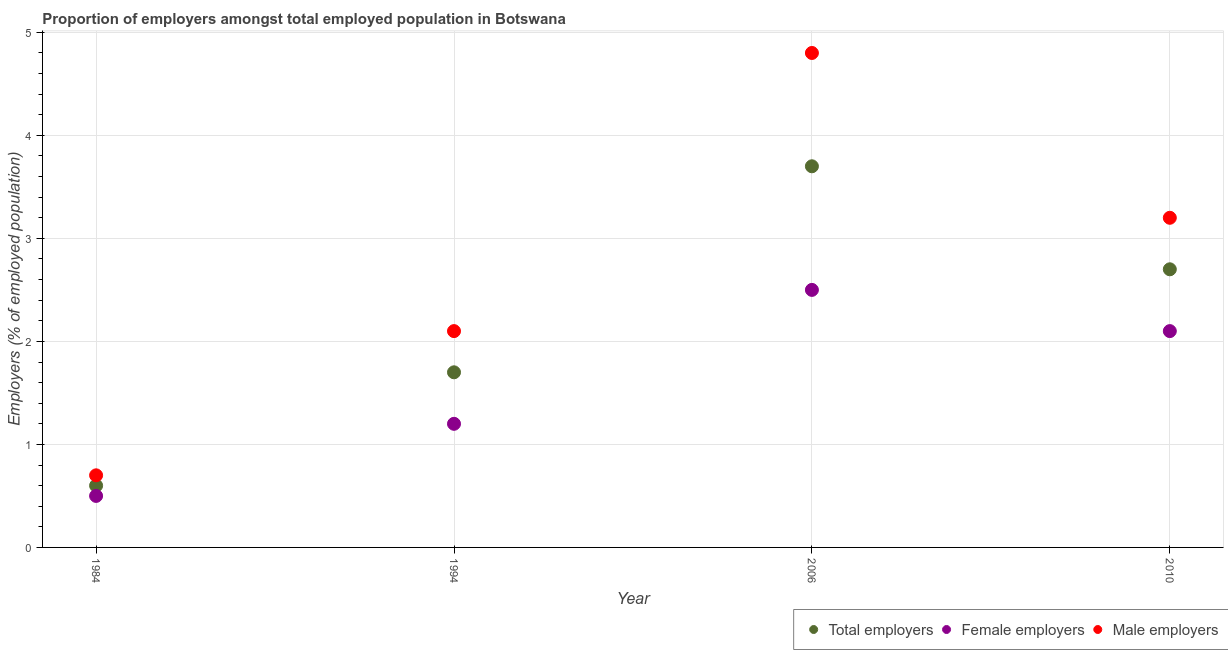How many different coloured dotlines are there?
Your answer should be very brief. 3. Is the number of dotlines equal to the number of legend labels?
Your answer should be very brief. Yes. What is the percentage of female employers in 1994?
Offer a terse response. 1.2. Across all years, what is the maximum percentage of total employers?
Provide a short and direct response. 3.7. Across all years, what is the minimum percentage of total employers?
Your response must be concise. 0.6. In which year was the percentage of total employers minimum?
Provide a short and direct response. 1984. What is the total percentage of total employers in the graph?
Keep it short and to the point. 8.7. What is the difference between the percentage of male employers in 1994 and that in 2010?
Your response must be concise. -1.1. What is the difference between the percentage of total employers in 1994 and the percentage of female employers in 2010?
Keep it short and to the point. -0.4. What is the average percentage of total employers per year?
Your response must be concise. 2.18. In the year 1984, what is the difference between the percentage of female employers and percentage of total employers?
Offer a very short reply. -0.1. In how many years, is the percentage of female employers greater than 3.8 %?
Give a very brief answer. 0. What is the ratio of the percentage of total employers in 2006 to that in 2010?
Keep it short and to the point. 1.37. Is the difference between the percentage of total employers in 1994 and 2010 greater than the difference between the percentage of male employers in 1994 and 2010?
Ensure brevity in your answer.  Yes. What is the difference between the highest and the second highest percentage of female employers?
Offer a terse response. 0.4. What is the difference between the highest and the lowest percentage of total employers?
Make the answer very short. 3.1. Does the percentage of male employers monotonically increase over the years?
Offer a terse response. No. Is the percentage of total employers strictly less than the percentage of male employers over the years?
Make the answer very short. Yes. How many dotlines are there?
Keep it short and to the point. 3. How many years are there in the graph?
Ensure brevity in your answer.  4. What is the difference between two consecutive major ticks on the Y-axis?
Your response must be concise. 1. Does the graph contain grids?
Your response must be concise. Yes. How are the legend labels stacked?
Offer a terse response. Horizontal. What is the title of the graph?
Provide a succinct answer. Proportion of employers amongst total employed population in Botswana. Does "Ages 0-14" appear as one of the legend labels in the graph?
Keep it short and to the point. No. What is the label or title of the X-axis?
Offer a terse response. Year. What is the label or title of the Y-axis?
Give a very brief answer. Employers (% of employed population). What is the Employers (% of employed population) in Total employers in 1984?
Ensure brevity in your answer.  0.6. What is the Employers (% of employed population) in Female employers in 1984?
Offer a terse response. 0.5. What is the Employers (% of employed population) of Male employers in 1984?
Provide a succinct answer. 0.7. What is the Employers (% of employed population) in Total employers in 1994?
Provide a short and direct response. 1.7. What is the Employers (% of employed population) in Female employers in 1994?
Ensure brevity in your answer.  1.2. What is the Employers (% of employed population) of Male employers in 1994?
Your answer should be very brief. 2.1. What is the Employers (% of employed population) in Total employers in 2006?
Your answer should be compact. 3.7. What is the Employers (% of employed population) of Female employers in 2006?
Your answer should be very brief. 2.5. What is the Employers (% of employed population) in Male employers in 2006?
Your response must be concise. 4.8. What is the Employers (% of employed population) of Total employers in 2010?
Provide a succinct answer. 2.7. What is the Employers (% of employed population) in Female employers in 2010?
Give a very brief answer. 2.1. What is the Employers (% of employed population) of Male employers in 2010?
Keep it short and to the point. 3.2. Across all years, what is the maximum Employers (% of employed population) in Total employers?
Ensure brevity in your answer.  3.7. Across all years, what is the maximum Employers (% of employed population) of Male employers?
Offer a terse response. 4.8. Across all years, what is the minimum Employers (% of employed population) of Total employers?
Provide a short and direct response. 0.6. Across all years, what is the minimum Employers (% of employed population) of Male employers?
Provide a short and direct response. 0.7. What is the total Employers (% of employed population) of Total employers in the graph?
Ensure brevity in your answer.  8.7. What is the total Employers (% of employed population) in Female employers in the graph?
Give a very brief answer. 6.3. What is the difference between the Employers (% of employed population) of Total employers in 1984 and that in 1994?
Provide a succinct answer. -1.1. What is the difference between the Employers (% of employed population) of Female employers in 1984 and that in 1994?
Your answer should be compact. -0.7. What is the difference between the Employers (% of employed population) in Total employers in 1984 and that in 2006?
Ensure brevity in your answer.  -3.1. What is the difference between the Employers (% of employed population) of Female employers in 1984 and that in 2006?
Give a very brief answer. -2. What is the difference between the Employers (% of employed population) of Male employers in 1984 and that in 2006?
Your answer should be very brief. -4.1. What is the difference between the Employers (% of employed population) in Male employers in 1984 and that in 2010?
Your response must be concise. -2.5. What is the difference between the Employers (% of employed population) in Total employers in 1994 and that in 2006?
Make the answer very short. -2. What is the difference between the Employers (% of employed population) in Female employers in 1994 and that in 2006?
Offer a terse response. -1.3. What is the difference between the Employers (% of employed population) of Male employers in 1994 and that in 2006?
Give a very brief answer. -2.7. What is the difference between the Employers (% of employed population) of Total employers in 1994 and that in 2010?
Your response must be concise. -1. What is the difference between the Employers (% of employed population) of Total employers in 2006 and that in 2010?
Your response must be concise. 1. What is the difference between the Employers (% of employed population) of Total employers in 1984 and the Employers (% of employed population) of Female employers in 1994?
Your answer should be compact. -0.6. What is the difference between the Employers (% of employed population) in Total employers in 1984 and the Employers (% of employed population) in Male employers in 1994?
Offer a very short reply. -1.5. What is the difference between the Employers (% of employed population) in Total employers in 1984 and the Employers (% of employed population) in Male employers in 2006?
Offer a terse response. -4.2. What is the difference between the Employers (% of employed population) of Female employers in 1984 and the Employers (% of employed population) of Male employers in 2010?
Make the answer very short. -2.7. What is the difference between the Employers (% of employed population) of Total employers in 1994 and the Employers (% of employed population) of Female employers in 2006?
Keep it short and to the point. -0.8. What is the difference between the Employers (% of employed population) in Total employers in 1994 and the Employers (% of employed population) in Male employers in 2006?
Provide a succinct answer. -3.1. What is the difference between the Employers (% of employed population) of Female employers in 1994 and the Employers (% of employed population) of Male employers in 2006?
Offer a very short reply. -3.6. What is the difference between the Employers (% of employed population) in Female employers in 1994 and the Employers (% of employed population) in Male employers in 2010?
Provide a short and direct response. -2. What is the average Employers (% of employed population) in Total employers per year?
Your answer should be compact. 2.17. What is the average Employers (% of employed population) in Female employers per year?
Your response must be concise. 1.57. What is the average Employers (% of employed population) of Male employers per year?
Offer a very short reply. 2.7. In the year 1984, what is the difference between the Employers (% of employed population) in Total employers and Employers (% of employed population) in Female employers?
Ensure brevity in your answer.  0.1. In the year 1994, what is the difference between the Employers (% of employed population) in Total employers and Employers (% of employed population) in Female employers?
Offer a very short reply. 0.5. In the year 1994, what is the difference between the Employers (% of employed population) of Total employers and Employers (% of employed population) of Male employers?
Give a very brief answer. -0.4. In the year 1994, what is the difference between the Employers (% of employed population) in Female employers and Employers (% of employed population) in Male employers?
Provide a succinct answer. -0.9. In the year 2006, what is the difference between the Employers (% of employed population) of Total employers and Employers (% of employed population) of Male employers?
Give a very brief answer. -1.1. In the year 2006, what is the difference between the Employers (% of employed population) of Female employers and Employers (% of employed population) of Male employers?
Offer a terse response. -2.3. In the year 2010, what is the difference between the Employers (% of employed population) in Total employers and Employers (% of employed population) in Female employers?
Keep it short and to the point. 0.6. What is the ratio of the Employers (% of employed population) in Total employers in 1984 to that in 1994?
Your answer should be very brief. 0.35. What is the ratio of the Employers (% of employed population) in Female employers in 1984 to that in 1994?
Your response must be concise. 0.42. What is the ratio of the Employers (% of employed population) of Total employers in 1984 to that in 2006?
Your response must be concise. 0.16. What is the ratio of the Employers (% of employed population) in Female employers in 1984 to that in 2006?
Keep it short and to the point. 0.2. What is the ratio of the Employers (% of employed population) of Male employers in 1984 to that in 2006?
Your answer should be very brief. 0.15. What is the ratio of the Employers (% of employed population) of Total employers in 1984 to that in 2010?
Your response must be concise. 0.22. What is the ratio of the Employers (% of employed population) of Female employers in 1984 to that in 2010?
Offer a very short reply. 0.24. What is the ratio of the Employers (% of employed population) in Male employers in 1984 to that in 2010?
Offer a very short reply. 0.22. What is the ratio of the Employers (% of employed population) of Total employers in 1994 to that in 2006?
Offer a very short reply. 0.46. What is the ratio of the Employers (% of employed population) in Female employers in 1994 to that in 2006?
Ensure brevity in your answer.  0.48. What is the ratio of the Employers (% of employed population) of Male employers in 1994 to that in 2006?
Your answer should be compact. 0.44. What is the ratio of the Employers (% of employed population) in Total employers in 1994 to that in 2010?
Give a very brief answer. 0.63. What is the ratio of the Employers (% of employed population) of Male employers in 1994 to that in 2010?
Your answer should be very brief. 0.66. What is the ratio of the Employers (% of employed population) in Total employers in 2006 to that in 2010?
Your answer should be compact. 1.37. What is the ratio of the Employers (% of employed population) in Female employers in 2006 to that in 2010?
Your response must be concise. 1.19. What is the ratio of the Employers (% of employed population) of Male employers in 2006 to that in 2010?
Keep it short and to the point. 1.5. What is the difference between the highest and the second highest Employers (% of employed population) of Total employers?
Your response must be concise. 1. What is the difference between the highest and the second highest Employers (% of employed population) of Female employers?
Offer a very short reply. 0.4. What is the difference between the highest and the second highest Employers (% of employed population) of Male employers?
Your answer should be compact. 1.6. What is the difference between the highest and the lowest Employers (% of employed population) in Female employers?
Provide a succinct answer. 2. What is the difference between the highest and the lowest Employers (% of employed population) of Male employers?
Your response must be concise. 4.1. 